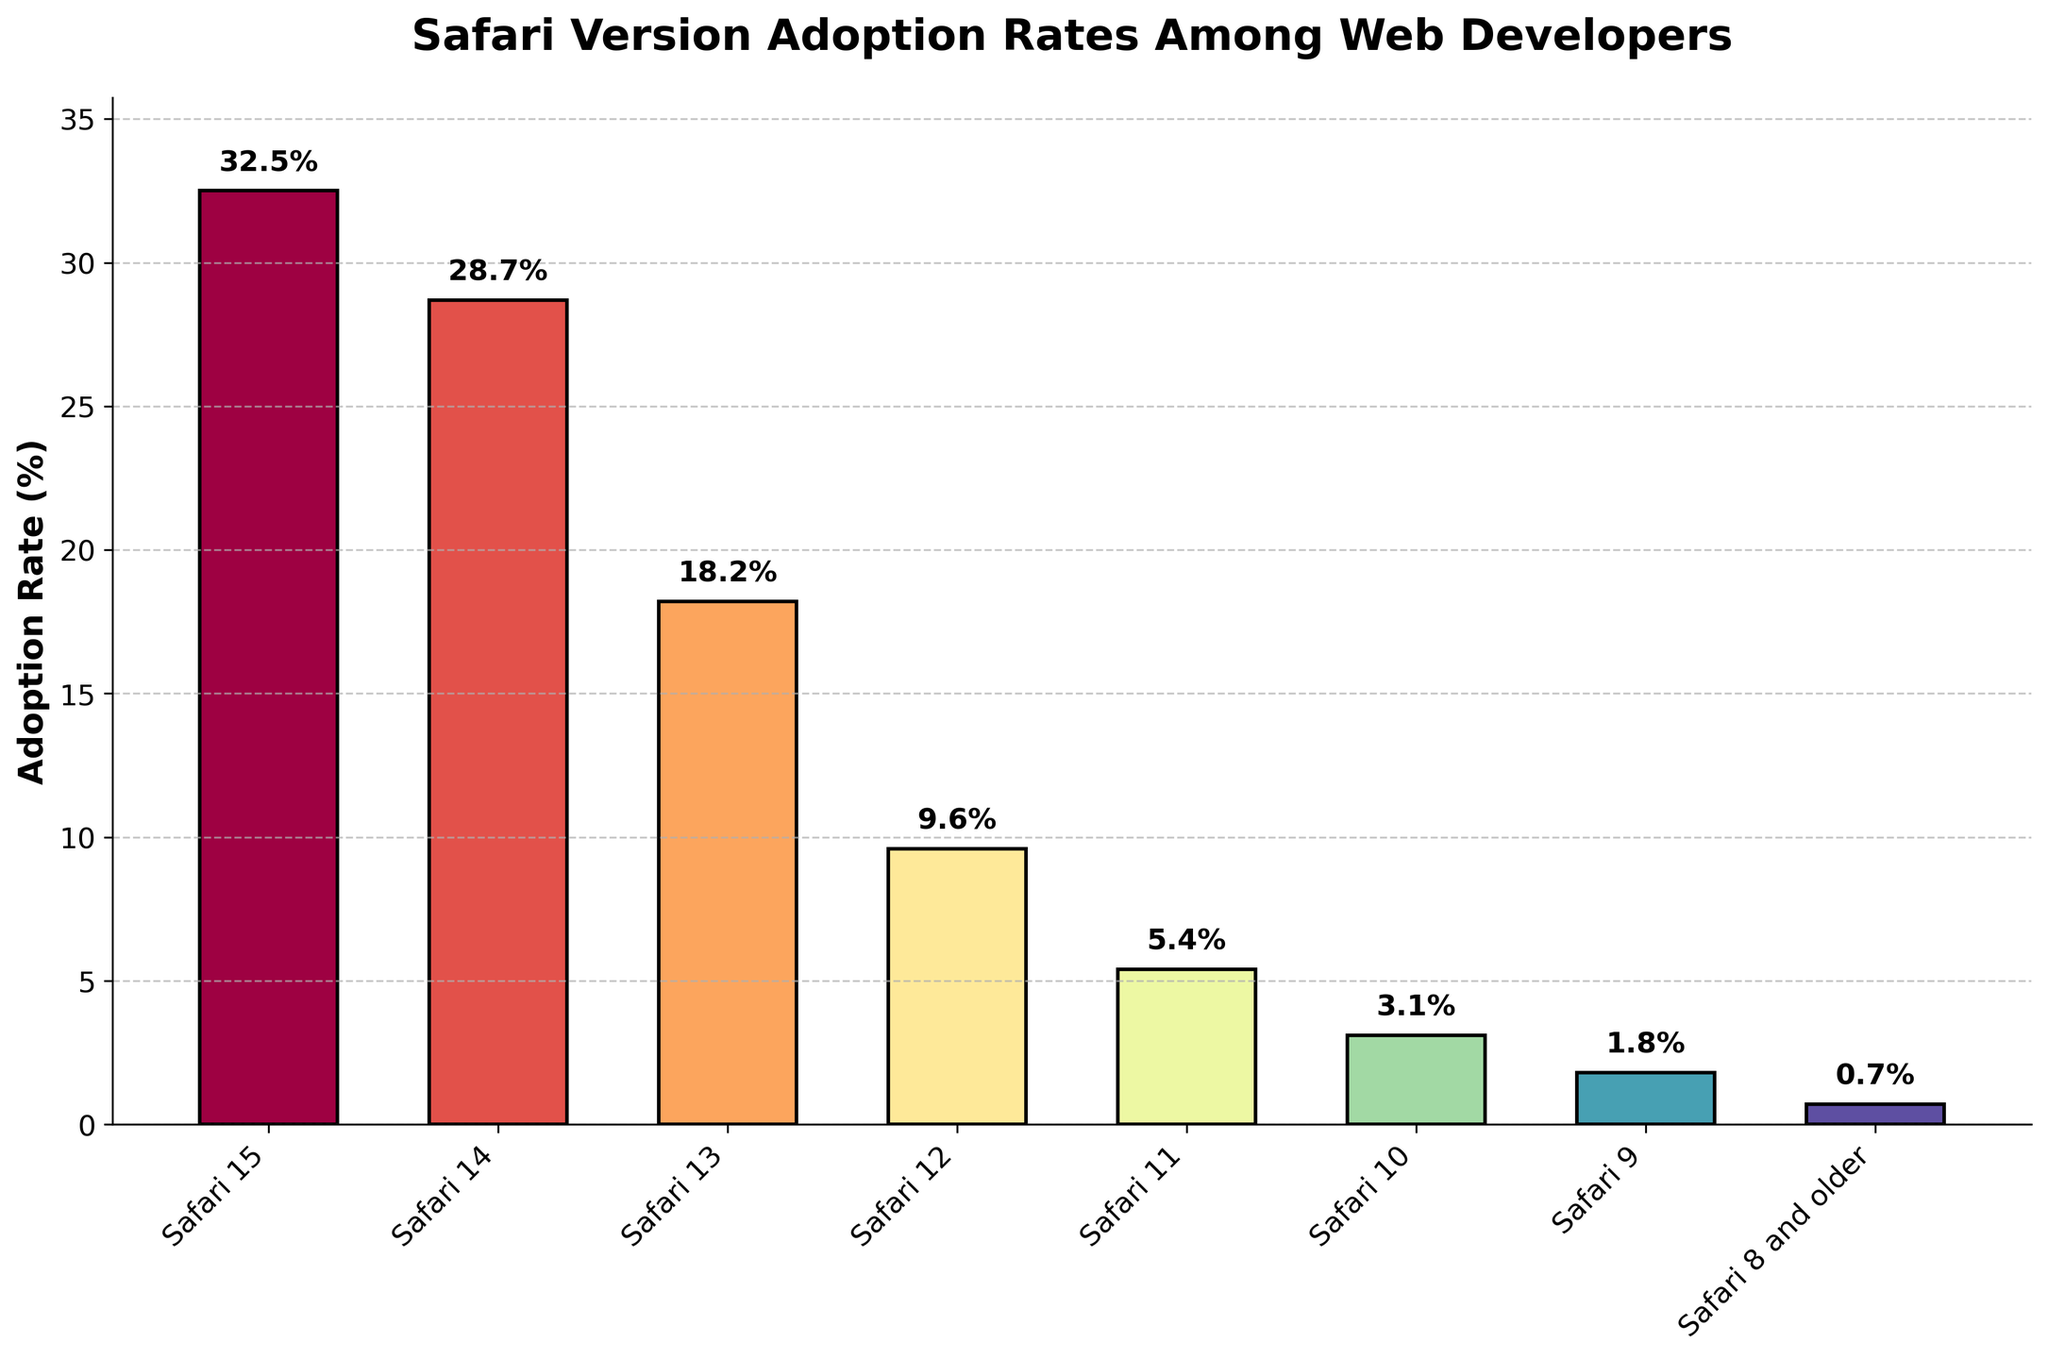Which Safari version has the highest adoption rate? Look at the bar representing each Safari version in the chart. The tallest bar indicates the highest adoption rate, which corresponds to Safari 15.
Answer: Safari 15 Which versions of Safari have an adoption rate greater than 20%? Identify the bars whose heights are above the 20% mark on the y-axis. These correspond to Safari 15 and Safari 14.
Answer: Safari 15 and Safari 14 What is the sum of the adoption rates for Safari 13 and Safari 12? Add the adoption rates of Safari 13 (18.2%) and Safari 12 (9.6%). Thus, 18.2% + 9.6% = 27.8%.
Answer: 27.8% How does the adoption rate of Safari 10 compare to the adoption rate of Safari 11? Compare the heights of the bars for Safari 10 and Safari 11. Safari 11 (5.4%) has a higher adoption rate than Safari 10 (3.1%).
Answer: Safari 11 is higher What is the average adoption rate of all Safari versions shown? Sum all the adoption rates and divide by the number of versions. \( \frac{(32.5 + 28.7 + 18.2 + 9.6 + 5.4 + 3.1 + 1.8 + 0.7)}{8} = \frac{100}{8} = 12.5 \)
Answer: 12.5% How many versions have an adoption rate less than 10%? Identify and count the bars whose heights are below the 10% mark on the y-axis. These correspond to Safari 12, Safari 11, Safari 10, Safari 9, and Safari 8 and older. There are 5 such versions.
Answer: 5 What is the difference in adoption rates between the most popular and the least popular Safari versions? Subtract the adoption rate of the least popular version (Safari 8 and older, 0.7%) from the most popular one (Safari 15, 32.5%). 32.5% - 0.7% = 31.8%.
Answer: 31.8% If we combine the adoption rates of Safari 14 and Safari 15, what percentage of web developers use these versions? Add the adoption rates of Safari 14 (28.7%) and Safari 15 (32.5%). 28.7% + 32.5% = 61.2%.
Answer: 61.2% Which Safari version’s adoption rate is closest to the median adoption rate of all the versions shown? Arrange the adoption rates in ascending order and find the median. The rates are: 0.7, 1.8, 3.1, 5.4, 9.6, 18.2, 28.7, and 32.5. The median between the 4th and 5th rates is (5.4+9.6)/2 = 7.5. Safari 12 (9.6%) is closest to this median.
Answer: Safari 12 